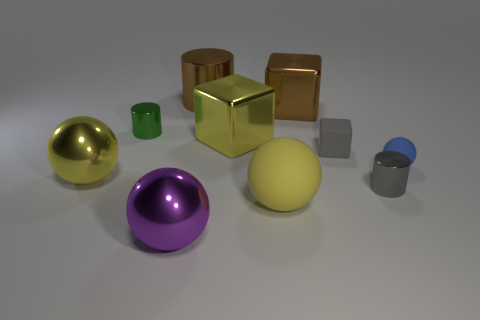Subtract all blocks. How many objects are left? 7 Add 9 tiny rubber blocks. How many tiny rubber blocks exist? 10 Subtract 1 brown cylinders. How many objects are left? 9 Subtract all big spheres. Subtract all blue matte spheres. How many objects are left? 6 Add 1 large purple objects. How many large purple objects are left? 2 